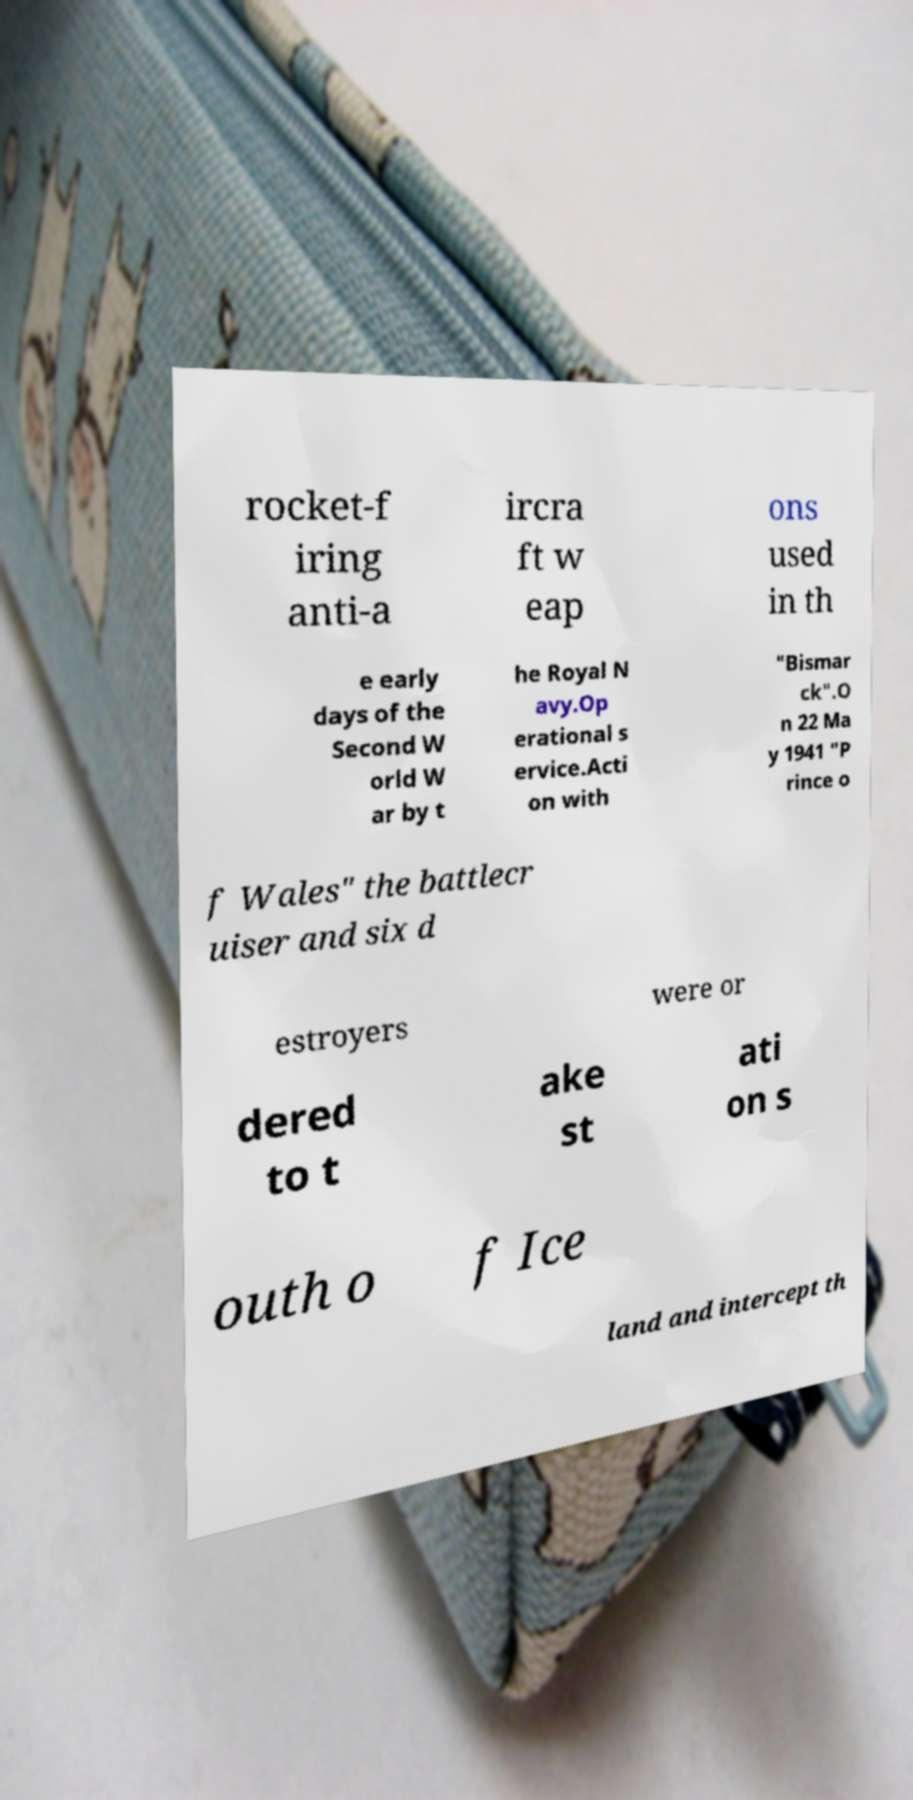Please identify and transcribe the text found in this image. rocket-f iring anti-a ircra ft w eap ons used in th e early days of the Second W orld W ar by t he Royal N avy.Op erational s ervice.Acti on with "Bismar ck".O n 22 Ma y 1941 "P rince o f Wales" the battlecr uiser and six d estroyers were or dered to t ake st ati on s outh o f Ice land and intercept th 